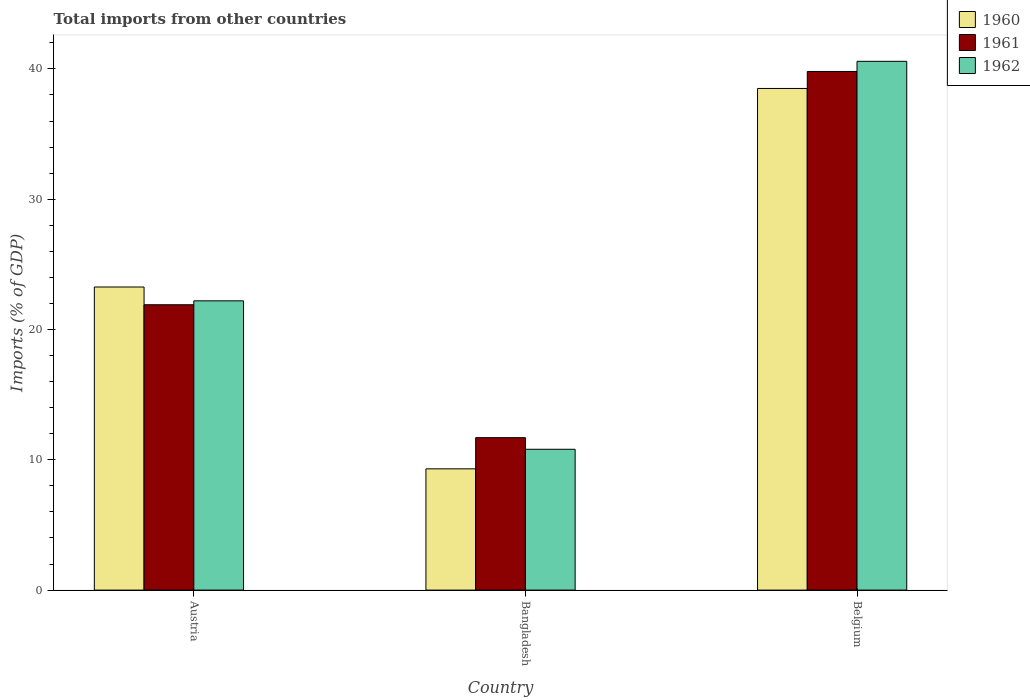How many different coloured bars are there?
Your response must be concise. 3. How many groups of bars are there?
Make the answer very short. 3. Are the number of bars per tick equal to the number of legend labels?
Offer a terse response. Yes. How many bars are there on the 1st tick from the left?
Ensure brevity in your answer.  3. What is the label of the 2nd group of bars from the left?
Keep it short and to the point. Bangladesh. In how many cases, is the number of bars for a given country not equal to the number of legend labels?
Offer a terse response. 0. What is the total imports in 1962 in Austria?
Ensure brevity in your answer.  22.2. Across all countries, what is the maximum total imports in 1960?
Give a very brief answer. 38.5. Across all countries, what is the minimum total imports in 1960?
Your answer should be compact. 9.31. In which country was the total imports in 1960 maximum?
Your answer should be very brief. Belgium. In which country was the total imports in 1962 minimum?
Provide a short and direct response. Bangladesh. What is the total total imports in 1962 in the graph?
Your answer should be very brief. 73.59. What is the difference between the total imports in 1960 in Austria and that in Bangladesh?
Make the answer very short. 13.95. What is the difference between the total imports in 1962 in Belgium and the total imports in 1961 in Austria?
Offer a terse response. 18.68. What is the average total imports in 1960 per country?
Your answer should be very brief. 23.69. What is the difference between the total imports of/in 1961 and total imports of/in 1960 in Bangladesh?
Make the answer very short. 2.39. What is the ratio of the total imports in 1960 in Austria to that in Bangladesh?
Make the answer very short. 2.5. Is the total imports in 1960 in Bangladesh less than that in Belgium?
Make the answer very short. Yes. What is the difference between the highest and the second highest total imports in 1961?
Ensure brevity in your answer.  -10.2. What is the difference between the highest and the lowest total imports in 1961?
Ensure brevity in your answer.  28.11. What does the 2nd bar from the left in Austria represents?
Your answer should be very brief. 1961. Is it the case that in every country, the sum of the total imports in 1960 and total imports in 1961 is greater than the total imports in 1962?
Keep it short and to the point. Yes. What is the title of the graph?
Ensure brevity in your answer.  Total imports from other countries. Does "1981" appear as one of the legend labels in the graph?
Your answer should be very brief. No. What is the label or title of the Y-axis?
Your response must be concise. Imports (% of GDP). What is the Imports (% of GDP) of 1960 in Austria?
Provide a short and direct response. 23.26. What is the Imports (% of GDP) in 1961 in Austria?
Offer a very short reply. 21.9. What is the Imports (% of GDP) in 1962 in Austria?
Your answer should be compact. 22.2. What is the Imports (% of GDP) in 1960 in Bangladesh?
Your response must be concise. 9.31. What is the Imports (% of GDP) of 1961 in Bangladesh?
Ensure brevity in your answer.  11.7. What is the Imports (% of GDP) of 1962 in Bangladesh?
Give a very brief answer. 10.81. What is the Imports (% of GDP) of 1960 in Belgium?
Offer a terse response. 38.5. What is the Imports (% of GDP) of 1961 in Belgium?
Your answer should be very brief. 39.81. What is the Imports (% of GDP) of 1962 in Belgium?
Keep it short and to the point. 40.58. Across all countries, what is the maximum Imports (% of GDP) in 1960?
Give a very brief answer. 38.5. Across all countries, what is the maximum Imports (% of GDP) in 1961?
Make the answer very short. 39.81. Across all countries, what is the maximum Imports (% of GDP) of 1962?
Your response must be concise. 40.58. Across all countries, what is the minimum Imports (% of GDP) of 1960?
Your answer should be compact. 9.31. Across all countries, what is the minimum Imports (% of GDP) in 1961?
Provide a short and direct response. 11.7. Across all countries, what is the minimum Imports (% of GDP) of 1962?
Give a very brief answer. 10.81. What is the total Imports (% of GDP) of 1960 in the graph?
Ensure brevity in your answer.  71.07. What is the total Imports (% of GDP) in 1961 in the graph?
Ensure brevity in your answer.  73.41. What is the total Imports (% of GDP) of 1962 in the graph?
Keep it short and to the point. 73.59. What is the difference between the Imports (% of GDP) of 1960 in Austria and that in Bangladesh?
Your response must be concise. 13.95. What is the difference between the Imports (% of GDP) in 1961 in Austria and that in Bangladesh?
Your answer should be very brief. 10.2. What is the difference between the Imports (% of GDP) of 1962 in Austria and that in Bangladesh?
Your answer should be compact. 11.39. What is the difference between the Imports (% of GDP) in 1960 in Austria and that in Belgium?
Keep it short and to the point. -15.24. What is the difference between the Imports (% of GDP) in 1961 in Austria and that in Belgium?
Keep it short and to the point. -17.9. What is the difference between the Imports (% of GDP) of 1962 in Austria and that in Belgium?
Make the answer very short. -18.38. What is the difference between the Imports (% of GDP) in 1960 in Bangladesh and that in Belgium?
Your answer should be very brief. -29.19. What is the difference between the Imports (% of GDP) in 1961 in Bangladesh and that in Belgium?
Give a very brief answer. -28.11. What is the difference between the Imports (% of GDP) in 1962 in Bangladesh and that in Belgium?
Provide a short and direct response. -29.78. What is the difference between the Imports (% of GDP) in 1960 in Austria and the Imports (% of GDP) in 1961 in Bangladesh?
Your answer should be compact. 11.56. What is the difference between the Imports (% of GDP) in 1960 in Austria and the Imports (% of GDP) in 1962 in Bangladesh?
Offer a very short reply. 12.45. What is the difference between the Imports (% of GDP) of 1961 in Austria and the Imports (% of GDP) of 1962 in Bangladesh?
Offer a terse response. 11.09. What is the difference between the Imports (% of GDP) in 1960 in Austria and the Imports (% of GDP) in 1961 in Belgium?
Provide a succinct answer. -16.54. What is the difference between the Imports (% of GDP) in 1960 in Austria and the Imports (% of GDP) in 1962 in Belgium?
Offer a terse response. -17.32. What is the difference between the Imports (% of GDP) in 1961 in Austria and the Imports (% of GDP) in 1962 in Belgium?
Provide a short and direct response. -18.68. What is the difference between the Imports (% of GDP) in 1960 in Bangladesh and the Imports (% of GDP) in 1961 in Belgium?
Make the answer very short. -30.5. What is the difference between the Imports (% of GDP) in 1960 in Bangladesh and the Imports (% of GDP) in 1962 in Belgium?
Provide a succinct answer. -31.28. What is the difference between the Imports (% of GDP) in 1961 in Bangladesh and the Imports (% of GDP) in 1962 in Belgium?
Your answer should be compact. -28.88. What is the average Imports (% of GDP) in 1960 per country?
Offer a very short reply. 23.69. What is the average Imports (% of GDP) of 1961 per country?
Provide a succinct answer. 24.47. What is the average Imports (% of GDP) in 1962 per country?
Ensure brevity in your answer.  24.53. What is the difference between the Imports (% of GDP) of 1960 and Imports (% of GDP) of 1961 in Austria?
Make the answer very short. 1.36. What is the difference between the Imports (% of GDP) of 1960 and Imports (% of GDP) of 1962 in Austria?
Provide a short and direct response. 1.06. What is the difference between the Imports (% of GDP) in 1961 and Imports (% of GDP) in 1962 in Austria?
Make the answer very short. -0.3. What is the difference between the Imports (% of GDP) of 1960 and Imports (% of GDP) of 1961 in Bangladesh?
Offer a terse response. -2.39. What is the difference between the Imports (% of GDP) of 1960 and Imports (% of GDP) of 1962 in Bangladesh?
Give a very brief answer. -1.5. What is the difference between the Imports (% of GDP) of 1961 and Imports (% of GDP) of 1962 in Bangladesh?
Provide a short and direct response. 0.89. What is the difference between the Imports (% of GDP) in 1960 and Imports (% of GDP) in 1961 in Belgium?
Keep it short and to the point. -1.3. What is the difference between the Imports (% of GDP) of 1960 and Imports (% of GDP) of 1962 in Belgium?
Your answer should be very brief. -2.08. What is the difference between the Imports (% of GDP) in 1961 and Imports (% of GDP) in 1962 in Belgium?
Your answer should be very brief. -0.78. What is the ratio of the Imports (% of GDP) of 1960 in Austria to that in Bangladesh?
Your answer should be compact. 2.5. What is the ratio of the Imports (% of GDP) in 1961 in Austria to that in Bangladesh?
Your answer should be compact. 1.87. What is the ratio of the Imports (% of GDP) of 1962 in Austria to that in Bangladesh?
Ensure brevity in your answer.  2.05. What is the ratio of the Imports (% of GDP) in 1960 in Austria to that in Belgium?
Make the answer very short. 0.6. What is the ratio of the Imports (% of GDP) in 1961 in Austria to that in Belgium?
Your answer should be compact. 0.55. What is the ratio of the Imports (% of GDP) in 1962 in Austria to that in Belgium?
Ensure brevity in your answer.  0.55. What is the ratio of the Imports (% of GDP) in 1960 in Bangladesh to that in Belgium?
Make the answer very short. 0.24. What is the ratio of the Imports (% of GDP) in 1961 in Bangladesh to that in Belgium?
Ensure brevity in your answer.  0.29. What is the ratio of the Imports (% of GDP) of 1962 in Bangladesh to that in Belgium?
Your answer should be compact. 0.27. What is the difference between the highest and the second highest Imports (% of GDP) in 1960?
Your answer should be compact. 15.24. What is the difference between the highest and the second highest Imports (% of GDP) of 1961?
Offer a terse response. 17.9. What is the difference between the highest and the second highest Imports (% of GDP) of 1962?
Give a very brief answer. 18.38. What is the difference between the highest and the lowest Imports (% of GDP) of 1960?
Give a very brief answer. 29.19. What is the difference between the highest and the lowest Imports (% of GDP) in 1961?
Make the answer very short. 28.11. What is the difference between the highest and the lowest Imports (% of GDP) of 1962?
Give a very brief answer. 29.78. 